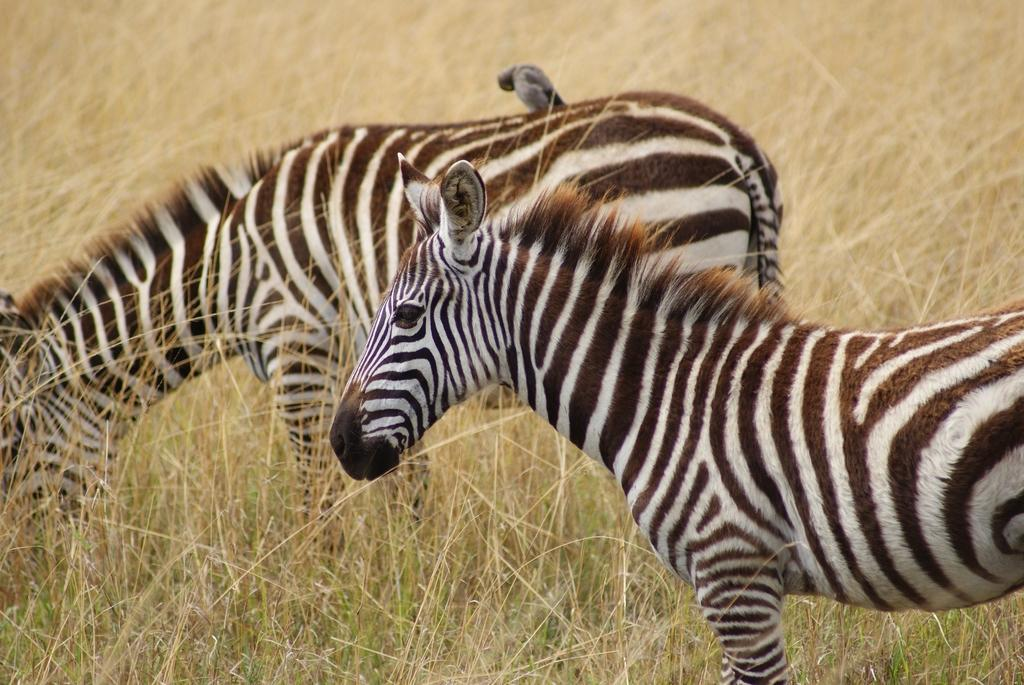How many zebras are in the image? There are two zebras in the image. What is the zebras' location in the image? The zebras are on the grass. Can you describe the possible setting of the image? The image may have been taken on a farm. What time of day might the image have been taken? The image may have been taken during the day. What type of apples are the zebras carrying on their journey in the image? There are no apples or journeys depicted in the image; it features two zebras on the grass. What type of work are the zebras engaged in during the image? There is no indication of work or any specific activity in the image; the zebras are simply on the grass. 